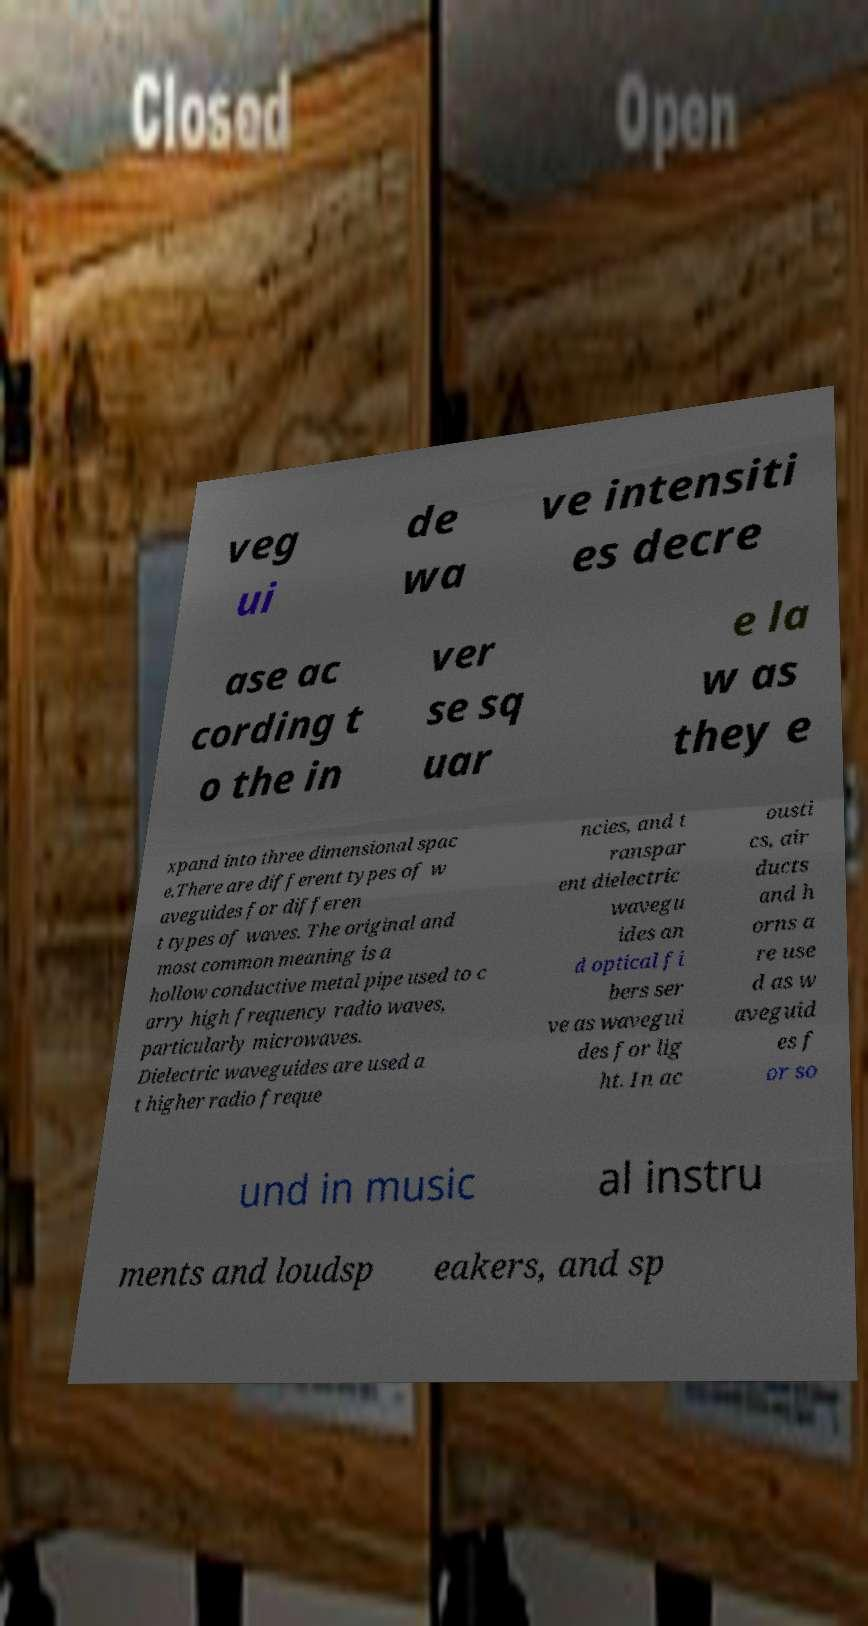Can you read and provide the text displayed in the image?This photo seems to have some interesting text. Can you extract and type it out for me? veg ui de wa ve intensiti es decre ase ac cording t o the in ver se sq uar e la w as they e xpand into three dimensional spac e.There are different types of w aveguides for differen t types of waves. The original and most common meaning is a hollow conductive metal pipe used to c arry high frequency radio waves, particularly microwaves. Dielectric waveguides are used a t higher radio freque ncies, and t ranspar ent dielectric wavegu ides an d optical fi bers ser ve as wavegui des for lig ht. In ac ousti cs, air ducts and h orns a re use d as w aveguid es f or so und in music al instru ments and loudsp eakers, and sp 